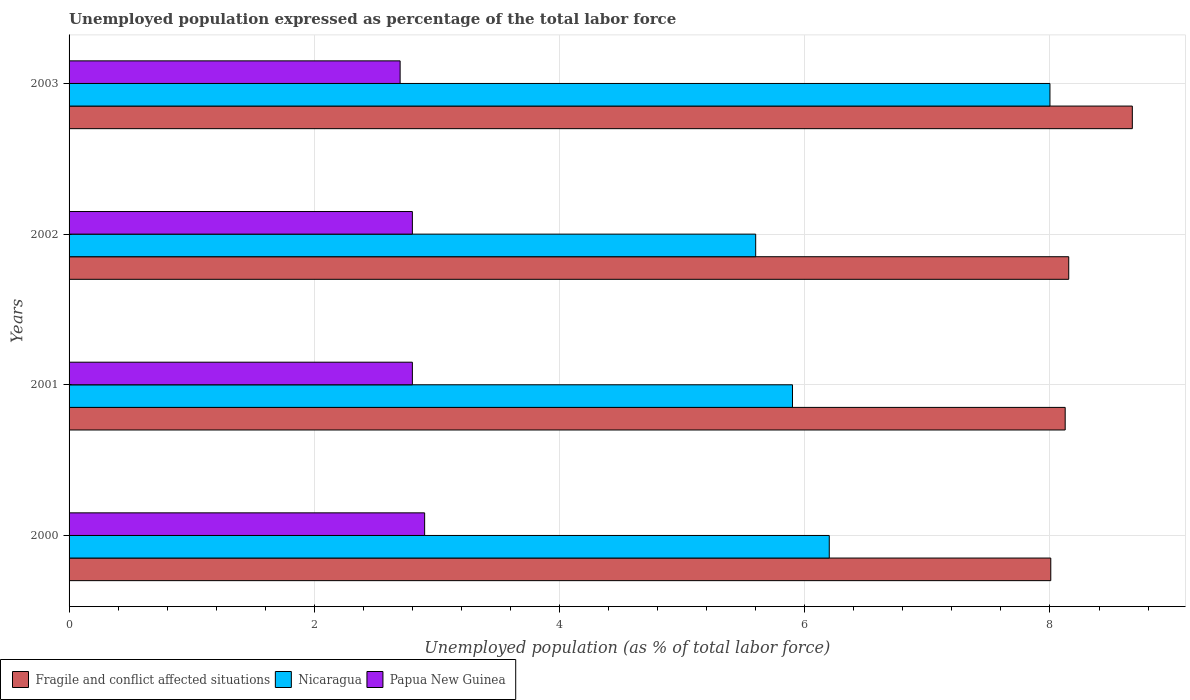How many different coloured bars are there?
Your answer should be very brief. 3. How many groups of bars are there?
Give a very brief answer. 4. Are the number of bars per tick equal to the number of legend labels?
Ensure brevity in your answer.  Yes. Are the number of bars on each tick of the Y-axis equal?
Ensure brevity in your answer.  Yes. What is the unemployment in in Fragile and conflict affected situations in 2003?
Provide a short and direct response. 8.67. Across all years, what is the maximum unemployment in in Nicaragua?
Your answer should be compact. 8. Across all years, what is the minimum unemployment in in Nicaragua?
Ensure brevity in your answer.  5.6. What is the total unemployment in in Nicaragua in the graph?
Provide a short and direct response. 25.7. What is the difference between the unemployment in in Nicaragua in 2000 and that in 2002?
Your answer should be compact. 0.6. What is the difference between the unemployment in in Fragile and conflict affected situations in 2001 and the unemployment in in Nicaragua in 2002?
Make the answer very short. 2.52. What is the average unemployment in in Fragile and conflict affected situations per year?
Your response must be concise. 8.24. In the year 2002, what is the difference between the unemployment in in Papua New Guinea and unemployment in in Fragile and conflict affected situations?
Ensure brevity in your answer.  -5.35. What is the ratio of the unemployment in in Nicaragua in 2000 to that in 2003?
Provide a succinct answer. 0.77. Is the unemployment in in Nicaragua in 2000 less than that in 2003?
Provide a short and direct response. Yes. Is the difference between the unemployment in in Papua New Guinea in 2000 and 2002 greater than the difference between the unemployment in in Fragile and conflict affected situations in 2000 and 2002?
Ensure brevity in your answer.  Yes. What is the difference between the highest and the second highest unemployment in in Papua New Guinea?
Give a very brief answer. 0.1. What is the difference between the highest and the lowest unemployment in in Papua New Guinea?
Give a very brief answer. 0.2. In how many years, is the unemployment in in Papua New Guinea greater than the average unemployment in in Papua New Guinea taken over all years?
Offer a very short reply. 1. Is the sum of the unemployment in in Fragile and conflict affected situations in 2000 and 2002 greater than the maximum unemployment in in Nicaragua across all years?
Make the answer very short. Yes. What does the 3rd bar from the top in 2001 represents?
Offer a terse response. Fragile and conflict affected situations. What does the 3rd bar from the bottom in 2003 represents?
Give a very brief answer. Papua New Guinea. Is it the case that in every year, the sum of the unemployment in in Nicaragua and unemployment in in Papua New Guinea is greater than the unemployment in in Fragile and conflict affected situations?
Your response must be concise. Yes. What is the difference between two consecutive major ticks on the X-axis?
Give a very brief answer. 2. Does the graph contain grids?
Provide a short and direct response. Yes. Where does the legend appear in the graph?
Give a very brief answer. Bottom left. How many legend labels are there?
Ensure brevity in your answer.  3. How are the legend labels stacked?
Your answer should be compact. Horizontal. What is the title of the graph?
Your answer should be very brief. Unemployed population expressed as percentage of the total labor force. Does "Faeroe Islands" appear as one of the legend labels in the graph?
Provide a succinct answer. No. What is the label or title of the X-axis?
Make the answer very short. Unemployed population (as % of total labor force). What is the label or title of the Y-axis?
Provide a succinct answer. Years. What is the Unemployed population (as % of total labor force) in Fragile and conflict affected situations in 2000?
Ensure brevity in your answer.  8.01. What is the Unemployed population (as % of total labor force) in Nicaragua in 2000?
Keep it short and to the point. 6.2. What is the Unemployed population (as % of total labor force) in Papua New Guinea in 2000?
Provide a short and direct response. 2.9. What is the Unemployed population (as % of total labor force) in Fragile and conflict affected situations in 2001?
Give a very brief answer. 8.12. What is the Unemployed population (as % of total labor force) in Nicaragua in 2001?
Your answer should be very brief. 5.9. What is the Unemployed population (as % of total labor force) in Papua New Guinea in 2001?
Ensure brevity in your answer.  2.8. What is the Unemployed population (as % of total labor force) in Fragile and conflict affected situations in 2002?
Your response must be concise. 8.15. What is the Unemployed population (as % of total labor force) in Nicaragua in 2002?
Your response must be concise. 5.6. What is the Unemployed population (as % of total labor force) in Papua New Guinea in 2002?
Ensure brevity in your answer.  2.8. What is the Unemployed population (as % of total labor force) in Fragile and conflict affected situations in 2003?
Provide a succinct answer. 8.67. What is the Unemployed population (as % of total labor force) of Papua New Guinea in 2003?
Keep it short and to the point. 2.7. Across all years, what is the maximum Unemployed population (as % of total labor force) of Fragile and conflict affected situations?
Your answer should be very brief. 8.67. Across all years, what is the maximum Unemployed population (as % of total labor force) in Papua New Guinea?
Offer a terse response. 2.9. Across all years, what is the minimum Unemployed population (as % of total labor force) of Fragile and conflict affected situations?
Offer a terse response. 8.01. Across all years, what is the minimum Unemployed population (as % of total labor force) of Nicaragua?
Your answer should be very brief. 5.6. Across all years, what is the minimum Unemployed population (as % of total labor force) of Papua New Guinea?
Your answer should be very brief. 2.7. What is the total Unemployed population (as % of total labor force) of Fragile and conflict affected situations in the graph?
Make the answer very short. 32.96. What is the total Unemployed population (as % of total labor force) of Nicaragua in the graph?
Provide a short and direct response. 25.7. What is the difference between the Unemployed population (as % of total labor force) of Fragile and conflict affected situations in 2000 and that in 2001?
Your answer should be compact. -0.12. What is the difference between the Unemployed population (as % of total labor force) of Fragile and conflict affected situations in 2000 and that in 2002?
Your response must be concise. -0.15. What is the difference between the Unemployed population (as % of total labor force) of Nicaragua in 2000 and that in 2002?
Provide a succinct answer. 0.6. What is the difference between the Unemployed population (as % of total labor force) of Fragile and conflict affected situations in 2000 and that in 2003?
Your answer should be compact. -0.67. What is the difference between the Unemployed population (as % of total labor force) of Papua New Guinea in 2000 and that in 2003?
Offer a very short reply. 0.2. What is the difference between the Unemployed population (as % of total labor force) in Fragile and conflict affected situations in 2001 and that in 2002?
Offer a very short reply. -0.03. What is the difference between the Unemployed population (as % of total labor force) in Nicaragua in 2001 and that in 2002?
Provide a succinct answer. 0.3. What is the difference between the Unemployed population (as % of total labor force) in Papua New Guinea in 2001 and that in 2002?
Your response must be concise. 0. What is the difference between the Unemployed population (as % of total labor force) of Fragile and conflict affected situations in 2001 and that in 2003?
Give a very brief answer. -0.55. What is the difference between the Unemployed population (as % of total labor force) in Nicaragua in 2001 and that in 2003?
Offer a terse response. -2.1. What is the difference between the Unemployed population (as % of total labor force) of Papua New Guinea in 2001 and that in 2003?
Offer a terse response. 0.1. What is the difference between the Unemployed population (as % of total labor force) in Fragile and conflict affected situations in 2002 and that in 2003?
Provide a succinct answer. -0.52. What is the difference between the Unemployed population (as % of total labor force) in Nicaragua in 2002 and that in 2003?
Offer a very short reply. -2.4. What is the difference between the Unemployed population (as % of total labor force) in Fragile and conflict affected situations in 2000 and the Unemployed population (as % of total labor force) in Nicaragua in 2001?
Your answer should be compact. 2.11. What is the difference between the Unemployed population (as % of total labor force) in Fragile and conflict affected situations in 2000 and the Unemployed population (as % of total labor force) in Papua New Guinea in 2001?
Offer a terse response. 5.21. What is the difference between the Unemployed population (as % of total labor force) in Fragile and conflict affected situations in 2000 and the Unemployed population (as % of total labor force) in Nicaragua in 2002?
Provide a short and direct response. 2.41. What is the difference between the Unemployed population (as % of total labor force) in Fragile and conflict affected situations in 2000 and the Unemployed population (as % of total labor force) in Papua New Guinea in 2002?
Keep it short and to the point. 5.21. What is the difference between the Unemployed population (as % of total labor force) in Nicaragua in 2000 and the Unemployed population (as % of total labor force) in Papua New Guinea in 2002?
Ensure brevity in your answer.  3.4. What is the difference between the Unemployed population (as % of total labor force) in Fragile and conflict affected situations in 2000 and the Unemployed population (as % of total labor force) in Nicaragua in 2003?
Offer a terse response. 0.01. What is the difference between the Unemployed population (as % of total labor force) of Fragile and conflict affected situations in 2000 and the Unemployed population (as % of total labor force) of Papua New Guinea in 2003?
Your response must be concise. 5.31. What is the difference between the Unemployed population (as % of total labor force) of Nicaragua in 2000 and the Unemployed population (as % of total labor force) of Papua New Guinea in 2003?
Make the answer very short. 3.5. What is the difference between the Unemployed population (as % of total labor force) of Fragile and conflict affected situations in 2001 and the Unemployed population (as % of total labor force) of Nicaragua in 2002?
Give a very brief answer. 2.52. What is the difference between the Unemployed population (as % of total labor force) of Fragile and conflict affected situations in 2001 and the Unemployed population (as % of total labor force) of Papua New Guinea in 2002?
Keep it short and to the point. 5.32. What is the difference between the Unemployed population (as % of total labor force) of Fragile and conflict affected situations in 2001 and the Unemployed population (as % of total labor force) of Nicaragua in 2003?
Give a very brief answer. 0.12. What is the difference between the Unemployed population (as % of total labor force) of Fragile and conflict affected situations in 2001 and the Unemployed population (as % of total labor force) of Papua New Guinea in 2003?
Your answer should be compact. 5.42. What is the difference between the Unemployed population (as % of total labor force) in Nicaragua in 2001 and the Unemployed population (as % of total labor force) in Papua New Guinea in 2003?
Give a very brief answer. 3.2. What is the difference between the Unemployed population (as % of total labor force) of Fragile and conflict affected situations in 2002 and the Unemployed population (as % of total labor force) of Nicaragua in 2003?
Give a very brief answer. 0.15. What is the difference between the Unemployed population (as % of total labor force) in Fragile and conflict affected situations in 2002 and the Unemployed population (as % of total labor force) in Papua New Guinea in 2003?
Provide a short and direct response. 5.45. What is the average Unemployed population (as % of total labor force) of Fragile and conflict affected situations per year?
Offer a terse response. 8.24. What is the average Unemployed population (as % of total labor force) in Nicaragua per year?
Make the answer very short. 6.42. What is the average Unemployed population (as % of total labor force) in Papua New Guinea per year?
Provide a short and direct response. 2.8. In the year 2000, what is the difference between the Unemployed population (as % of total labor force) in Fragile and conflict affected situations and Unemployed population (as % of total labor force) in Nicaragua?
Your response must be concise. 1.81. In the year 2000, what is the difference between the Unemployed population (as % of total labor force) of Fragile and conflict affected situations and Unemployed population (as % of total labor force) of Papua New Guinea?
Give a very brief answer. 5.11. In the year 2001, what is the difference between the Unemployed population (as % of total labor force) of Fragile and conflict affected situations and Unemployed population (as % of total labor force) of Nicaragua?
Keep it short and to the point. 2.22. In the year 2001, what is the difference between the Unemployed population (as % of total labor force) in Fragile and conflict affected situations and Unemployed population (as % of total labor force) in Papua New Guinea?
Offer a very short reply. 5.32. In the year 2002, what is the difference between the Unemployed population (as % of total labor force) in Fragile and conflict affected situations and Unemployed population (as % of total labor force) in Nicaragua?
Your response must be concise. 2.55. In the year 2002, what is the difference between the Unemployed population (as % of total labor force) in Fragile and conflict affected situations and Unemployed population (as % of total labor force) in Papua New Guinea?
Keep it short and to the point. 5.35. In the year 2003, what is the difference between the Unemployed population (as % of total labor force) of Fragile and conflict affected situations and Unemployed population (as % of total labor force) of Nicaragua?
Provide a short and direct response. 0.67. In the year 2003, what is the difference between the Unemployed population (as % of total labor force) of Fragile and conflict affected situations and Unemployed population (as % of total labor force) of Papua New Guinea?
Offer a terse response. 5.97. In the year 2003, what is the difference between the Unemployed population (as % of total labor force) in Nicaragua and Unemployed population (as % of total labor force) in Papua New Guinea?
Keep it short and to the point. 5.3. What is the ratio of the Unemployed population (as % of total labor force) in Fragile and conflict affected situations in 2000 to that in 2001?
Make the answer very short. 0.99. What is the ratio of the Unemployed population (as % of total labor force) of Nicaragua in 2000 to that in 2001?
Keep it short and to the point. 1.05. What is the ratio of the Unemployed population (as % of total labor force) of Papua New Guinea in 2000 to that in 2001?
Your response must be concise. 1.04. What is the ratio of the Unemployed population (as % of total labor force) in Nicaragua in 2000 to that in 2002?
Give a very brief answer. 1.11. What is the ratio of the Unemployed population (as % of total labor force) in Papua New Guinea in 2000 to that in 2002?
Provide a short and direct response. 1.04. What is the ratio of the Unemployed population (as % of total labor force) of Fragile and conflict affected situations in 2000 to that in 2003?
Your response must be concise. 0.92. What is the ratio of the Unemployed population (as % of total labor force) in Nicaragua in 2000 to that in 2003?
Provide a short and direct response. 0.78. What is the ratio of the Unemployed population (as % of total labor force) of Papua New Guinea in 2000 to that in 2003?
Provide a short and direct response. 1.07. What is the ratio of the Unemployed population (as % of total labor force) in Fragile and conflict affected situations in 2001 to that in 2002?
Ensure brevity in your answer.  1. What is the ratio of the Unemployed population (as % of total labor force) of Nicaragua in 2001 to that in 2002?
Keep it short and to the point. 1.05. What is the ratio of the Unemployed population (as % of total labor force) in Papua New Guinea in 2001 to that in 2002?
Provide a succinct answer. 1. What is the ratio of the Unemployed population (as % of total labor force) of Fragile and conflict affected situations in 2001 to that in 2003?
Give a very brief answer. 0.94. What is the ratio of the Unemployed population (as % of total labor force) of Nicaragua in 2001 to that in 2003?
Keep it short and to the point. 0.74. What is the ratio of the Unemployed population (as % of total labor force) of Fragile and conflict affected situations in 2002 to that in 2003?
Offer a very short reply. 0.94. What is the ratio of the Unemployed population (as % of total labor force) in Nicaragua in 2002 to that in 2003?
Keep it short and to the point. 0.7. What is the difference between the highest and the second highest Unemployed population (as % of total labor force) in Fragile and conflict affected situations?
Ensure brevity in your answer.  0.52. What is the difference between the highest and the lowest Unemployed population (as % of total labor force) in Fragile and conflict affected situations?
Provide a succinct answer. 0.67. What is the difference between the highest and the lowest Unemployed population (as % of total labor force) of Papua New Guinea?
Your answer should be compact. 0.2. 